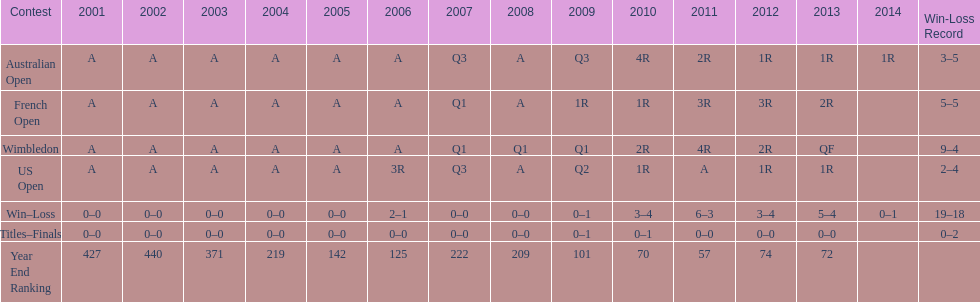In which year was the highest year-end ranking attained? 2011. 